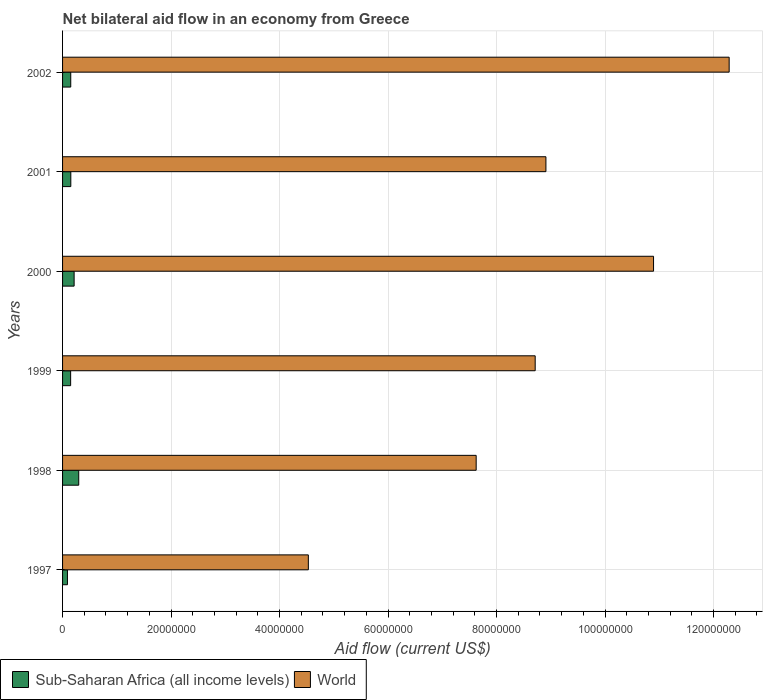How many groups of bars are there?
Your answer should be very brief. 6. Are the number of bars on each tick of the Y-axis equal?
Keep it short and to the point. Yes. How many bars are there on the 1st tick from the bottom?
Your answer should be compact. 2. What is the label of the 2nd group of bars from the top?
Provide a short and direct response. 2001. What is the net bilateral aid flow in Sub-Saharan Africa (all income levels) in 1997?
Offer a terse response. 9.00e+05. Across all years, what is the maximum net bilateral aid flow in Sub-Saharan Africa (all income levels)?
Give a very brief answer. 2.98e+06. Across all years, what is the minimum net bilateral aid flow in Sub-Saharan Africa (all income levels)?
Your response must be concise. 9.00e+05. In which year was the net bilateral aid flow in Sub-Saharan Africa (all income levels) maximum?
Provide a short and direct response. 1998. What is the total net bilateral aid flow in World in the graph?
Your answer should be very brief. 5.30e+08. What is the difference between the net bilateral aid flow in Sub-Saharan Africa (all income levels) in 1997 and that in 2001?
Give a very brief answer. -6.20e+05. What is the difference between the net bilateral aid flow in Sub-Saharan Africa (all income levels) in 1997 and the net bilateral aid flow in World in 1999?
Ensure brevity in your answer.  -8.62e+07. What is the average net bilateral aid flow in World per year?
Keep it short and to the point. 8.83e+07. In the year 1999, what is the difference between the net bilateral aid flow in Sub-Saharan Africa (all income levels) and net bilateral aid flow in World?
Your response must be concise. -8.56e+07. In how many years, is the net bilateral aid flow in Sub-Saharan Africa (all income levels) greater than 80000000 US$?
Provide a succinct answer. 0. What is the ratio of the net bilateral aid flow in Sub-Saharan Africa (all income levels) in 1997 to that in 2001?
Your answer should be compact. 0.59. Is the net bilateral aid flow in Sub-Saharan Africa (all income levels) in 1997 less than that in 1999?
Keep it short and to the point. Yes. What is the difference between the highest and the second highest net bilateral aid flow in World?
Provide a succinct answer. 1.39e+07. What is the difference between the highest and the lowest net bilateral aid flow in Sub-Saharan Africa (all income levels)?
Your answer should be very brief. 2.08e+06. In how many years, is the net bilateral aid flow in Sub-Saharan Africa (all income levels) greater than the average net bilateral aid flow in Sub-Saharan Africa (all income levels) taken over all years?
Give a very brief answer. 2. Is the sum of the net bilateral aid flow in World in 1999 and 2000 greater than the maximum net bilateral aid flow in Sub-Saharan Africa (all income levels) across all years?
Your answer should be very brief. Yes. What does the 2nd bar from the top in 2002 represents?
Give a very brief answer. Sub-Saharan Africa (all income levels). How many bars are there?
Provide a short and direct response. 12. Are all the bars in the graph horizontal?
Offer a terse response. Yes. How many years are there in the graph?
Offer a very short reply. 6. What is the difference between two consecutive major ticks on the X-axis?
Offer a terse response. 2.00e+07. Does the graph contain grids?
Provide a short and direct response. Yes. How are the legend labels stacked?
Offer a terse response. Horizontal. What is the title of the graph?
Keep it short and to the point. Net bilateral aid flow in an economy from Greece. Does "Vietnam" appear as one of the legend labels in the graph?
Ensure brevity in your answer.  No. What is the Aid flow (current US$) in World in 1997?
Provide a short and direct response. 4.53e+07. What is the Aid flow (current US$) in Sub-Saharan Africa (all income levels) in 1998?
Make the answer very short. 2.98e+06. What is the Aid flow (current US$) of World in 1998?
Your answer should be very brief. 7.62e+07. What is the Aid flow (current US$) in Sub-Saharan Africa (all income levels) in 1999?
Offer a very short reply. 1.49e+06. What is the Aid flow (current US$) of World in 1999?
Provide a short and direct response. 8.71e+07. What is the Aid flow (current US$) in Sub-Saharan Africa (all income levels) in 2000?
Make the answer very short. 2.13e+06. What is the Aid flow (current US$) of World in 2000?
Give a very brief answer. 1.09e+08. What is the Aid flow (current US$) of Sub-Saharan Africa (all income levels) in 2001?
Offer a very short reply. 1.52e+06. What is the Aid flow (current US$) in World in 2001?
Keep it short and to the point. 8.91e+07. What is the Aid flow (current US$) of Sub-Saharan Africa (all income levels) in 2002?
Keep it short and to the point. 1.51e+06. What is the Aid flow (current US$) of World in 2002?
Give a very brief answer. 1.23e+08. Across all years, what is the maximum Aid flow (current US$) of Sub-Saharan Africa (all income levels)?
Keep it short and to the point. 2.98e+06. Across all years, what is the maximum Aid flow (current US$) in World?
Provide a short and direct response. 1.23e+08. Across all years, what is the minimum Aid flow (current US$) in Sub-Saharan Africa (all income levels)?
Your response must be concise. 9.00e+05. Across all years, what is the minimum Aid flow (current US$) of World?
Offer a terse response. 4.53e+07. What is the total Aid flow (current US$) in Sub-Saharan Africa (all income levels) in the graph?
Give a very brief answer. 1.05e+07. What is the total Aid flow (current US$) of World in the graph?
Your answer should be compact. 5.30e+08. What is the difference between the Aid flow (current US$) in Sub-Saharan Africa (all income levels) in 1997 and that in 1998?
Ensure brevity in your answer.  -2.08e+06. What is the difference between the Aid flow (current US$) in World in 1997 and that in 1998?
Provide a short and direct response. -3.09e+07. What is the difference between the Aid flow (current US$) in Sub-Saharan Africa (all income levels) in 1997 and that in 1999?
Provide a succinct answer. -5.90e+05. What is the difference between the Aid flow (current US$) of World in 1997 and that in 1999?
Ensure brevity in your answer.  -4.18e+07. What is the difference between the Aid flow (current US$) in Sub-Saharan Africa (all income levels) in 1997 and that in 2000?
Your answer should be compact. -1.23e+06. What is the difference between the Aid flow (current US$) of World in 1997 and that in 2000?
Your answer should be very brief. -6.36e+07. What is the difference between the Aid flow (current US$) of Sub-Saharan Africa (all income levels) in 1997 and that in 2001?
Offer a very short reply. -6.20e+05. What is the difference between the Aid flow (current US$) of World in 1997 and that in 2001?
Keep it short and to the point. -4.38e+07. What is the difference between the Aid flow (current US$) in Sub-Saharan Africa (all income levels) in 1997 and that in 2002?
Keep it short and to the point. -6.10e+05. What is the difference between the Aid flow (current US$) of World in 1997 and that in 2002?
Offer a terse response. -7.76e+07. What is the difference between the Aid flow (current US$) in Sub-Saharan Africa (all income levels) in 1998 and that in 1999?
Ensure brevity in your answer.  1.49e+06. What is the difference between the Aid flow (current US$) in World in 1998 and that in 1999?
Your answer should be very brief. -1.09e+07. What is the difference between the Aid flow (current US$) of Sub-Saharan Africa (all income levels) in 1998 and that in 2000?
Your answer should be very brief. 8.50e+05. What is the difference between the Aid flow (current US$) in World in 1998 and that in 2000?
Offer a very short reply. -3.27e+07. What is the difference between the Aid flow (current US$) of Sub-Saharan Africa (all income levels) in 1998 and that in 2001?
Make the answer very short. 1.46e+06. What is the difference between the Aid flow (current US$) in World in 1998 and that in 2001?
Ensure brevity in your answer.  -1.29e+07. What is the difference between the Aid flow (current US$) in Sub-Saharan Africa (all income levels) in 1998 and that in 2002?
Offer a terse response. 1.47e+06. What is the difference between the Aid flow (current US$) in World in 1998 and that in 2002?
Ensure brevity in your answer.  -4.66e+07. What is the difference between the Aid flow (current US$) of Sub-Saharan Africa (all income levels) in 1999 and that in 2000?
Make the answer very short. -6.40e+05. What is the difference between the Aid flow (current US$) in World in 1999 and that in 2000?
Your answer should be compact. -2.18e+07. What is the difference between the Aid flow (current US$) of Sub-Saharan Africa (all income levels) in 1999 and that in 2001?
Make the answer very short. -3.00e+04. What is the difference between the Aid flow (current US$) of World in 1999 and that in 2001?
Provide a succinct answer. -1.98e+06. What is the difference between the Aid flow (current US$) in World in 1999 and that in 2002?
Give a very brief answer. -3.58e+07. What is the difference between the Aid flow (current US$) in Sub-Saharan Africa (all income levels) in 2000 and that in 2001?
Provide a short and direct response. 6.10e+05. What is the difference between the Aid flow (current US$) of World in 2000 and that in 2001?
Ensure brevity in your answer.  1.98e+07. What is the difference between the Aid flow (current US$) of Sub-Saharan Africa (all income levels) in 2000 and that in 2002?
Make the answer very short. 6.20e+05. What is the difference between the Aid flow (current US$) in World in 2000 and that in 2002?
Ensure brevity in your answer.  -1.39e+07. What is the difference between the Aid flow (current US$) of World in 2001 and that in 2002?
Your answer should be very brief. -3.38e+07. What is the difference between the Aid flow (current US$) in Sub-Saharan Africa (all income levels) in 1997 and the Aid flow (current US$) in World in 1998?
Your response must be concise. -7.54e+07. What is the difference between the Aid flow (current US$) in Sub-Saharan Africa (all income levels) in 1997 and the Aid flow (current US$) in World in 1999?
Make the answer very short. -8.62e+07. What is the difference between the Aid flow (current US$) of Sub-Saharan Africa (all income levels) in 1997 and the Aid flow (current US$) of World in 2000?
Provide a short and direct response. -1.08e+08. What is the difference between the Aid flow (current US$) of Sub-Saharan Africa (all income levels) in 1997 and the Aid flow (current US$) of World in 2001?
Provide a succinct answer. -8.82e+07. What is the difference between the Aid flow (current US$) in Sub-Saharan Africa (all income levels) in 1997 and the Aid flow (current US$) in World in 2002?
Make the answer very short. -1.22e+08. What is the difference between the Aid flow (current US$) in Sub-Saharan Africa (all income levels) in 1998 and the Aid flow (current US$) in World in 1999?
Provide a short and direct response. -8.42e+07. What is the difference between the Aid flow (current US$) of Sub-Saharan Africa (all income levels) in 1998 and the Aid flow (current US$) of World in 2000?
Keep it short and to the point. -1.06e+08. What is the difference between the Aid flow (current US$) in Sub-Saharan Africa (all income levels) in 1998 and the Aid flow (current US$) in World in 2001?
Your answer should be compact. -8.61e+07. What is the difference between the Aid flow (current US$) of Sub-Saharan Africa (all income levels) in 1998 and the Aid flow (current US$) of World in 2002?
Your answer should be very brief. -1.20e+08. What is the difference between the Aid flow (current US$) in Sub-Saharan Africa (all income levels) in 1999 and the Aid flow (current US$) in World in 2000?
Ensure brevity in your answer.  -1.07e+08. What is the difference between the Aid flow (current US$) in Sub-Saharan Africa (all income levels) in 1999 and the Aid flow (current US$) in World in 2001?
Provide a succinct answer. -8.76e+07. What is the difference between the Aid flow (current US$) of Sub-Saharan Africa (all income levels) in 1999 and the Aid flow (current US$) of World in 2002?
Ensure brevity in your answer.  -1.21e+08. What is the difference between the Aid flow (current US$) in Sub-Saharan Africa (all income levels) in 2000 and the Aid flow (current US$) in World in 2001?
Give a very brief answer. -8.70e+07. What is the difference between the Aid flow (current US$) in Sub-Saharan Africa (all income levels) in 2000 and the Aid flow (current US$) in World in 2002?
Offer a very short reply. -1.21e+08. What is the difference between the Aid flow (current US$) in Sub-Saharan Africa (all income levels) in 2001 and the Aid flow (current US$) in World in 2002?
Provide a short and direct response. -1.21e+08. What is the average Aid flow (current US$) of Sub-Saharan Africa (all income levels) per year?
Provide a short and direct response. 1.76e+06. What is the average Aid flow (current US$) of World per year?
Offer a terse response. 8.83e+07. In the year 1997, what is the difference between the Aid flow (current US$) of Sub-Saharan Africa (all income levels) and Aid flow (current US$) of World?
Offer a very short reply. -4.44e+07. In the year 1998, what is the difference between the Aid flow (current US$) of Sub-Saharan Africa (all income levels) and Aid flow (current US$) of World?
Offer a terse response. -7.33e+07. In the year 1999, what is the difference between the Aid flow (current US$) in Sub-Saharan Africa (all income levels) and Aid flow (current US$) in World?
Ensure brevity in your answer.  -8.56e+07. In the year 2000, what is the difference between the Aid flow (current US$) in Sub-Saharan Africa (all income levels) and Aid flow (current US$) in World?
Keep it short and to the point. -1.07e+08. In the year 2001, what is the difference between the Aid flow (current US$) in Sub-Saharan Africa (all income levels) and Aid flow (current US$) in World?
Offer a very short reply. -8.76e+07. In the year 2002, what is the difference between the Aid flow (current US$) in Sub-Saharan Africa (all income levels) and Aid flow (current US$) in World?
Give a very brief answer. -1.21e+08. What is the ratio of the Aid flow (current US$) of Sub-Saharan Africa (all income levels) in 1997 to that in 1998?
Make the answer very short. 0.3. What is the ratio of the Aid flow (current US$) in World in 1997 to that in 1998?
Your response must be concise. 0.59. What is the ratio of the Aid flow (current US$) of Sub-Saharan Africa (all income levels) in 1997 to that in 1999?
Give a very brief answer. 0.6. What is the ratio of the Aid flow (current US$) of World in 1997 to that in 1999?
Provide a succinct answer. 0.52. What is the ratio of the Aid flow (current US$) of Sub-Saharan Africa (all income levels) in 1997 to that in 2000?
Offer a very short reply. 0.42. What is the ratio of the Aid flow (current US$) of World in 1997 to that in 2000?
Offer a terse response. 0.42. What is the ratio of the Aid flow (current US$) in Sub-Saharan Africa (all income levels) in 1997 to that in 2001?
Your answer should be compact. 0.59. What is the ratio of the Aid flow (current US$) of World in 1997 to that in 2001?
Your response must be concise. 0.51. What is the ratio of the Aid flow (current US$) in Sub-Saharan Africa (all income levels) in 1997 to that in 2002?
Offer a very short reply. 0.6. What is the ratio of the Aid flow (current US$) of World in 1997 to that in 2002?
Make the answer very short. 0.37. What is the ratio of the Aid flow (current US$) in Sub-Saharan Africa (all income levels) in 1998 to that in 1999?
Your answer should be very brief. 2. What is the ratio of the Aid flow (current US$) of World in 1998 to that in 1999?
Offer a very short reply. 0.88. What is the ratio of the Aid flow (current US$) of Sub-Saharan Africa (all income levels) in 1998 to that in 2000?
Provide a succinct answer. 1.4. What is the ratio of the Aid flow (current US$) in World in 1998 to that in 2000?
Keep it short and to the point. 0.7. What is the ratio of the Aid flow (current US$) of Sub-Saharan Africa (all income levels) in 1998 to that in 2001?
Your answer should be very brief. 1.96. What is the ratio of the Aid flow (current US$) of World in 1998 to that in 2001?
Offer a terse response. 0.86. What is the ratio of the Aid flow (current US$) in Sub-Saharan Africa (all income levels) in 1998 to that in 2002?
Your response must be concise. 1.97. What is the ratio of the Aid flow (current US$) of World in 1998 to that in 2002?
Give a very brief answer. 0.62. What is the ratio of the Aid flow (current US$) of Sub-Saharan Africa (all income levels) in 1999 to that in 2000?
Offer a very short reply. 0.7. What is the ratio of the Aid flow (current US$) in World in 1999 to that in 2000?
Make the answer very short. 0.8. What is the ratio of the Aid flow (current US$) of Sub-Saharan Africa (all income levels) in 1999 to that in 2001?
Offer a very short reply. 0.98. What is the ratio of the Aid flow (current US$) of World in 1999 to that in 2001?
Offer a very short reply. 0.98. What is the ratio of the Aid flow (current US$) in World in 1999 to that in 2002?
Give a very brief answer. 0.71. What is the ratio of the Aid flow (current US$) of Sub-Saharan Africa (all income levels) in 2000 to that in 2001?
Your response must be concise. 1.4. What is the ratio of the Aid flow (current US$) in World in 2000 to that in 2001?
Offer a terse response. 1.22. What is the ratio of the Aid flow (current US$) in Sub-Saharan Africa (all income levels) in 2000 to that in 2002?
Your response must be concise. 1.41. What is the ratio of the Aid flow (current US$) in World in 2000 to that in 2002?
Offer a very short reply. 0.89. What is the ratio of the Aid flow (current US$) of Sub-Saharan Africa (all income levels) in 2001 to that in 2002?
Provide a short and direct response. 1.01. What is the ratio of the Aid flow (current US$) in World in 2001 to that in 2002?
Keep it short and to the point. 0.73. What is the difference between the highest and the second highest Aid flow (current US$) in Sub-Saharan Africa (all income levels)?
Give a very brief answer. 8.50e+05. What is the difference between the highest and the second highest Aid flow (current US$) in World?
Your response must be concise. 1.39e+07. What is the difference between the highest and the lowest Aid flow (current US$) of Sub-Saharan Africa (all income levels)?
Provide a succinct answer. 2.08e+06. What is the difference between the highest and the lowest Aid flow (current US$) of World?
Your response must be concise. 7.76e+07. 